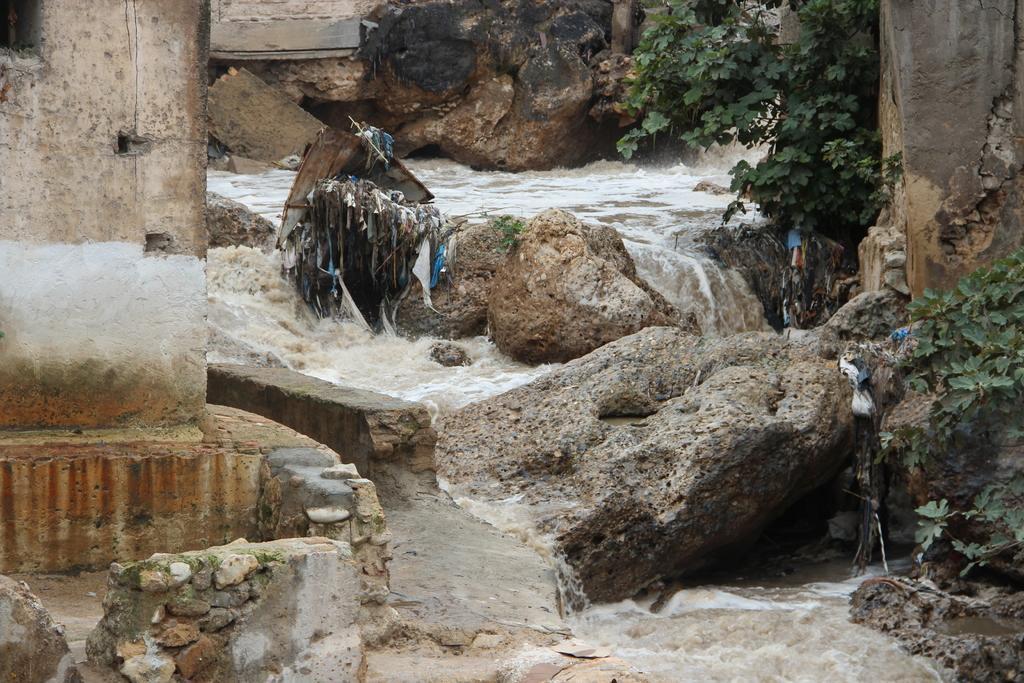Can you describe this image briefly? In this picture we can see rocks and plants and we can see water in the background. 